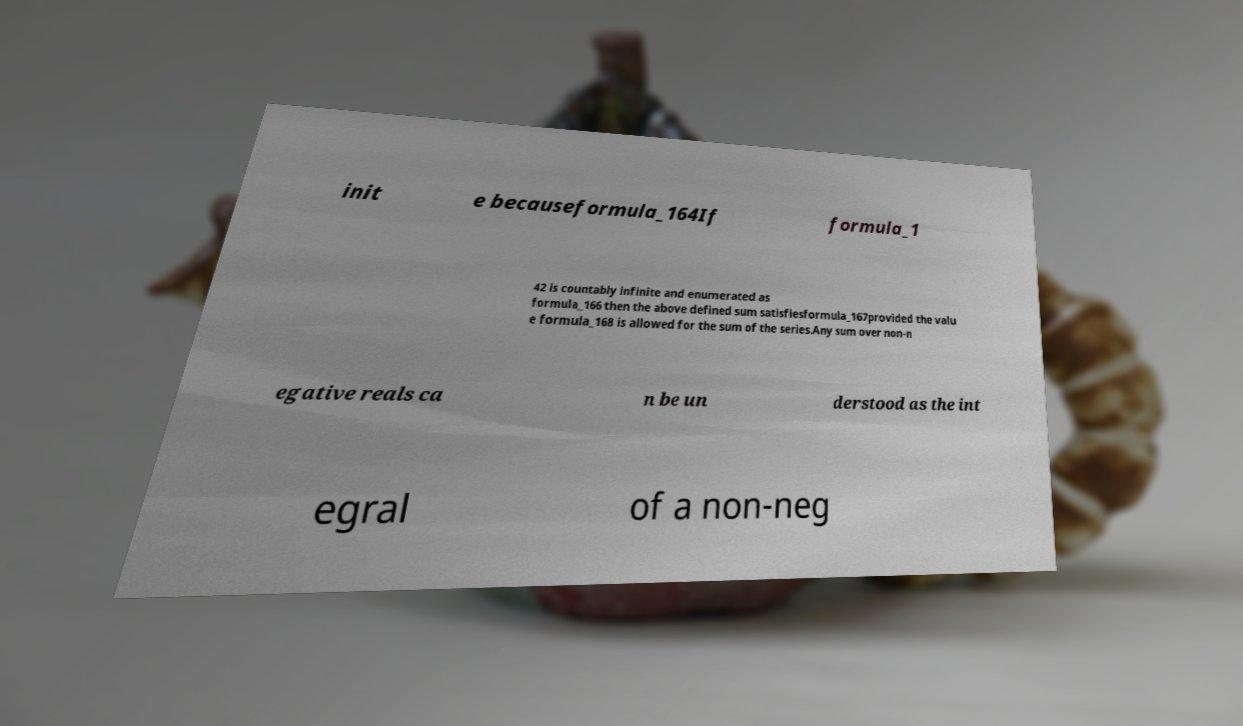Please read and relay the text visible in this image. What does it say? init e becauseformula_164If formula_1 42 is countably infinite and enumerated as formula_166 then the above defined sum satisfiesformula_167provided the valu e formula_168 is allowed for the sum of the series.Any sum over non-n egative reals ca n be un derstood as the int egral of a non-neg 